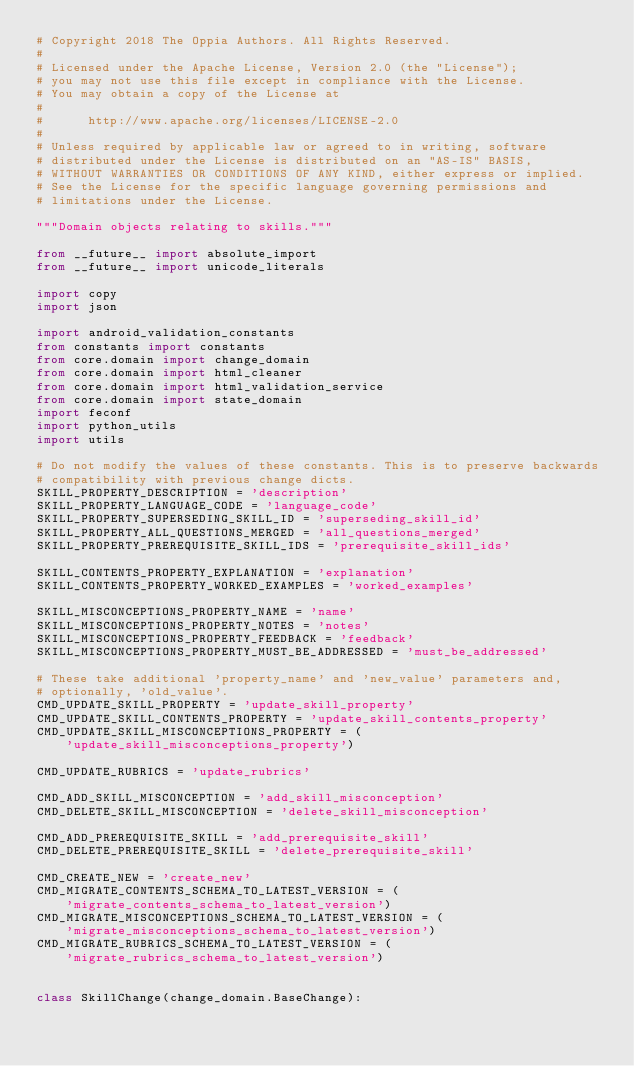Convert code to text. <code><loc_0><loc_0><loc_500><loc_500><_Python_># Copyright 2018 The Oppia Authors. All Rights Reserved.
#
# Licensed under the Apache License, Version 2.0 (the "License");
# you may not use this file except in compliance with the License.
# You may obtain a copy of the License at
#
#      http://www.apache.org/licenses/LICENSE-2.0
#
# Unless required by applicable law or agreed to in writing, software
# distributed under the License is distributed on an "AS-IS" BASIS,
# WITHOUT WARRANTIES OR CONDITIONS OF ANY KIND, either express or implied.
# See the License for the specific language governing permissions and
# limitations under the License.

"""Domain objects relating to skills."""

from __future__ import absolute_import
from __future__ import unicode_literals

import copy
import json

import android_validation_constants
from constants import constants
from core.domain import change_domain
from core.domain import html_cleaner
from core.domain import html_validation_service
from core.domain import state_domain
import feconf
import python_utils
import utils

# Do not modify the values of these constants. This is to preserve backwards
# compatibility with previous change dicts.
SKILL_PROPERTY_DESCRIPTION = 'description'
SKILL_PROPERTY_LANGUAGE_CODE = 'language_code'
SKILL_PROPERTY_SUPERSEDING_SKILL_ID = 'superseding_skill_id'
SKILL_PROPERTY_ALL_QUESTIONS_MERGED = 'all_questions_merged'
SKILL_PROPERTY_PREREQUISITE_SKILL_IDS = 'prerequisite_skill_ids'

SKILL_CONTENTS_PROPERTY_EXPLANATION = 'explanation'
SKILL_CONTENTS_PROPERTY_WORKED_EXAMPLES = 'worked_examples'

SKILL_MISCONCEPTIONS_PROPERTY_NAME = 'name'
SKILL_MISCONCEPTIONS_PROPERTY_NOTES = 'notes'
SKILL_MISCONCEPTIONS_PROPERTY_FEEDBACK = 'feedback'
SKILL_MISCONCEPTIONS_PROPERTY_MUST_BE_ADDRESSED = 'must_be_addressed'

# These take additional 'property_name' and 'new_value' parameters and,
# optionally, 'old_value'.
CMD_UPDATE_SKILL_PROPERTY = 'update_skill_property'
CMD_UPDATE_SKILL_CONTENTS_PROPERTY = 'update_skill_contents_property'
CMD_UPDATE_SKILL_MISCONCEPTIONS_PROPERTY = (
    'update_skill_misconceptions_property')

CMD_UPDATE_RUBRICS = 'update_rubrics'

CMD_ADD_SKILL_MISCONCEPTION = 'add_skill_misconception'
CMD_DELETE_SKILL_MISCONCEPTION = 'delete_skill_misconception'

CMD_ADD_PREREQUISITE_SKILL = 'add_prerequisite_skill'
CMD_DELETE_PREREQUISITE_SKILL = 'delete_prerequisite_skill'

CMD_CREATE_NEW = 'create_new'
CMD_MIGRATE_CONTENTS_SCHEMA_TO_LATEST_VERSION = (
    'migrate_contents_schema_to_latest_version')
CMD_MIGRATE_MISCONCEPTIONS_SCHEMA_TO_LATEST_VERSION = (
    'migrate_misconceptions_schema_to_latest_version')
CMD_MIGRATE_RUBRICS_SCHEMA_TO_LATEST_VERSION = (
    'migrate_rubrics_schema_to_latest_version')


class SkillChange(change_domain.BaseChange):</code> 